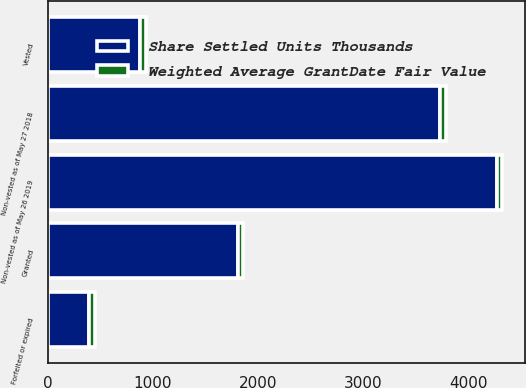Convert chart. <chart><loc_0><loc_0><loc_500><loc_500><stacked_bar_chart><ecel><fcel>Non-vested as of May 27 2018<fcel>Granted<fcel>Vested<fcel>Forfeited or expired<fcel>Non-vested as of May 26 2019<nl><fcel>Share Settled Units Thousands<fcel>3731.8<fcel>1814.5<fcel>880.6<fcel>393.4<fcel>4272.3<nl><fcel>Weighted Average GrantDate Fair Value<fcel>57.5<fcel>46.14<fcel>51.3<fcel>58.44<fcel>53.87<nl></chart> 